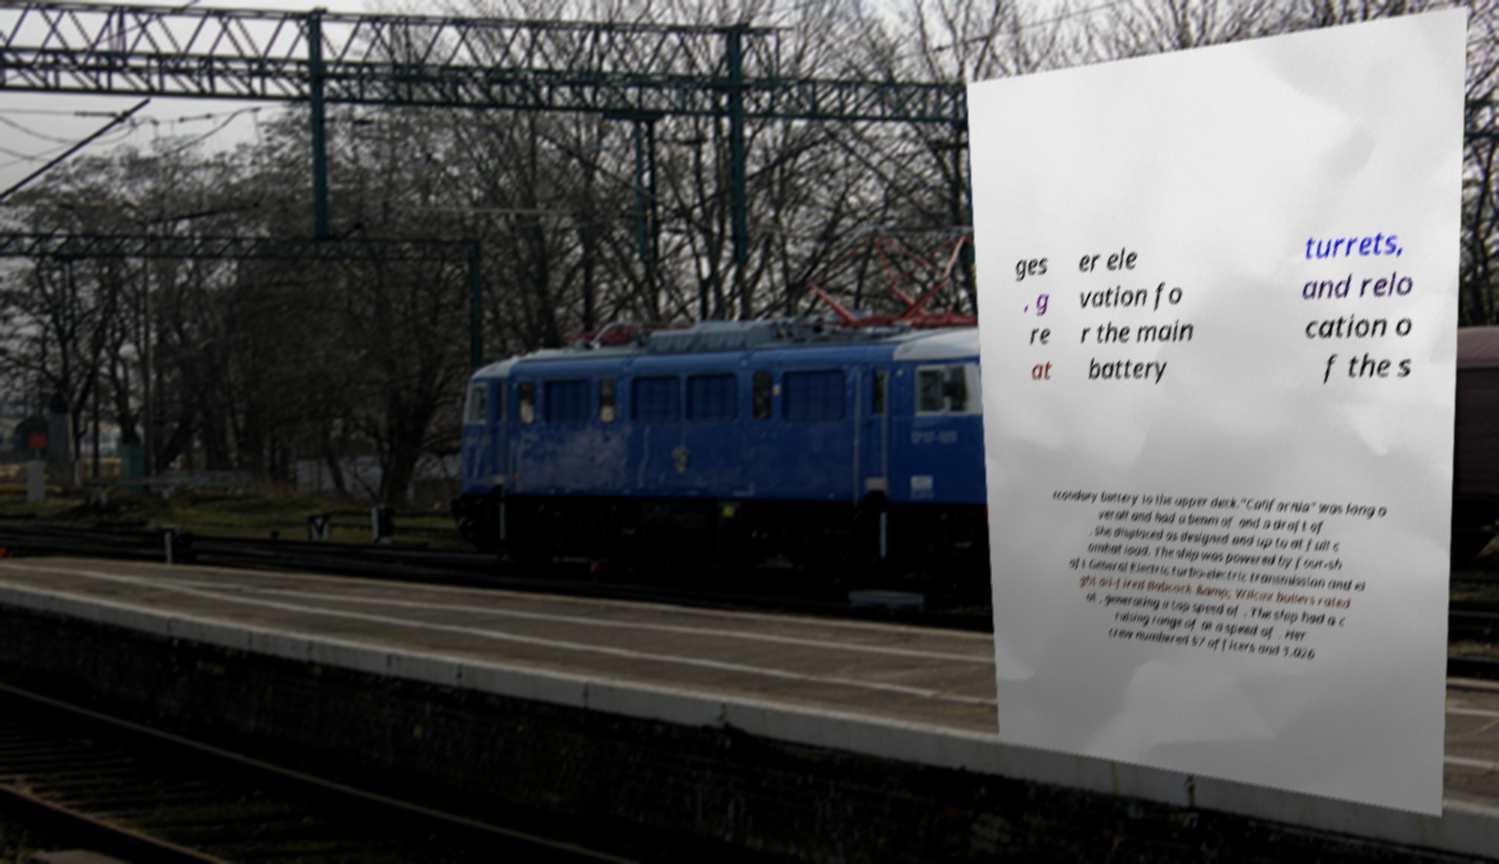I need the written content from this picture converted into text. Can you do that? ges , g re at er ele vation fo r the main battery turrets, and relo cation o f the s econdary battery to the upper deck."California" was long o verall and had a beam of and a draft of . She displaced as designed and up to at full c ombat load. The ship was powered by four-sh aft General Electric turbo-electric transmission and ei ght oil-fired Babcock &amp; Wilcox boilers rated at , generating a top speed of . The ship had a c ruising range of at a speed of . Her crew numbered 57 officers and 1,026 